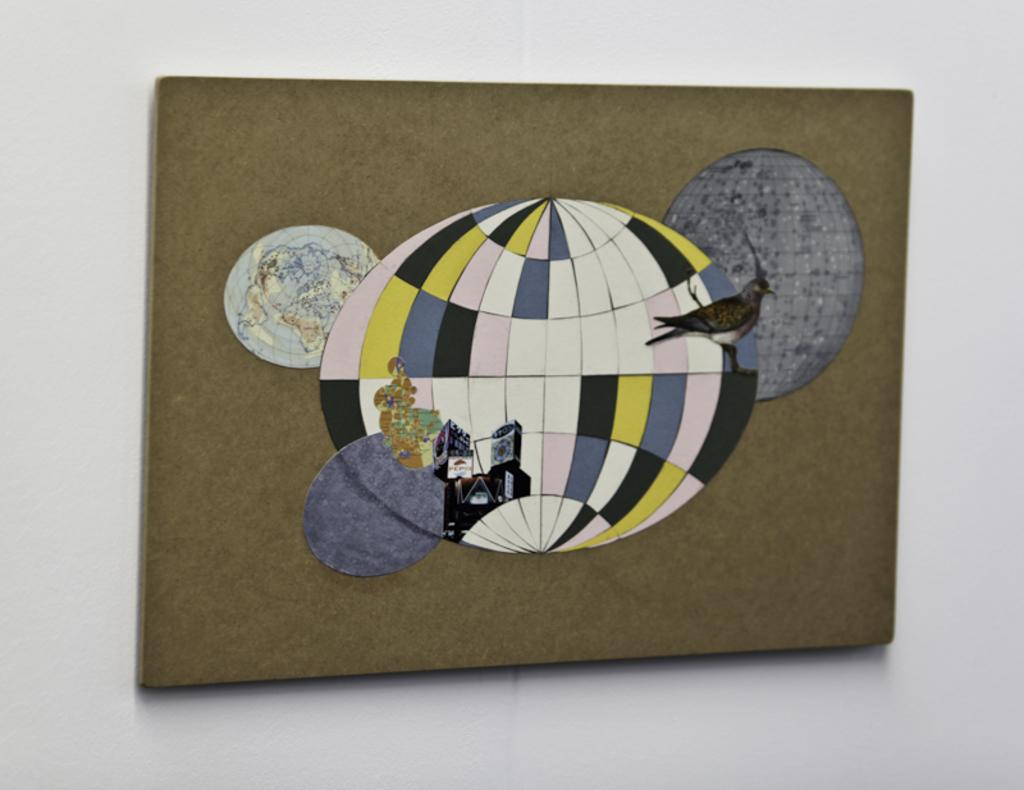What type of animal is shown in the image? There is a bird depicted in the image. Is there a boy holding a giraffe in the image? No, there is no boy or giraffe present in the image; it only features a bird. 